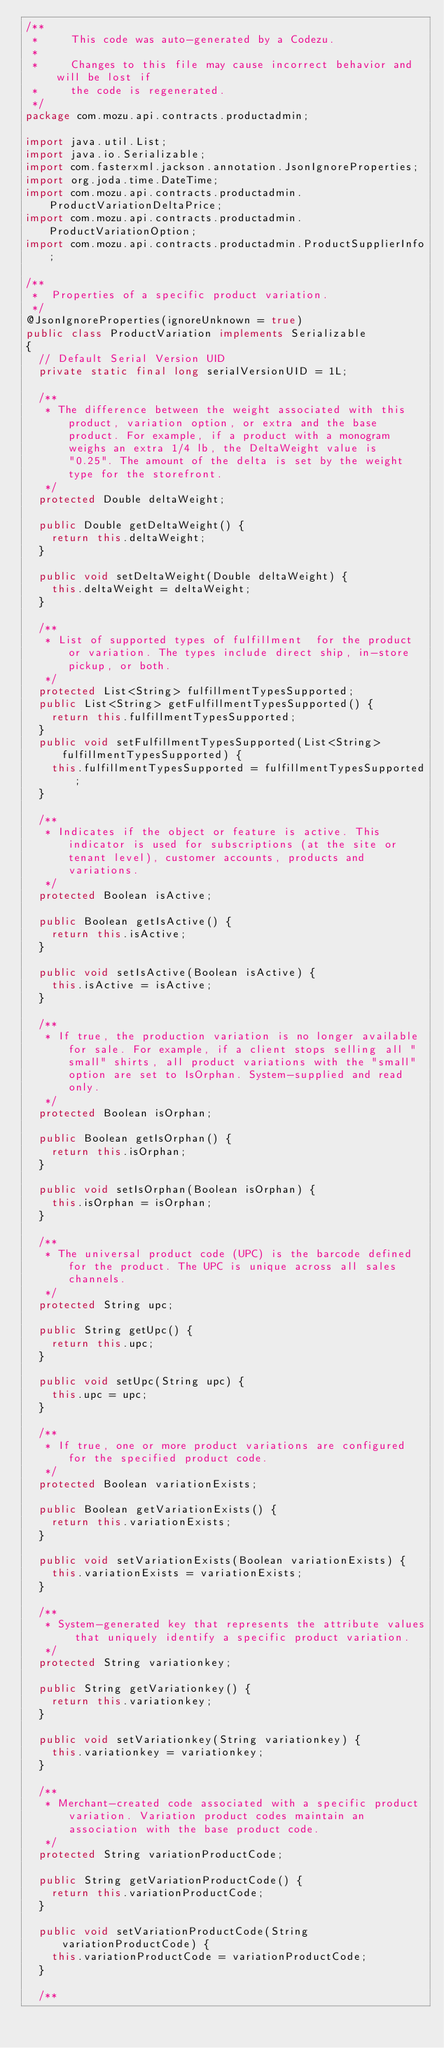Convert code to text. <code><loc_0><loc_0><loc_500><loc_500><_Java_>/**
 *     This code was auto-generated by a Codezu.     
 *
 *     Changes to this file may cause incorrect behavior and will be lost if
 *     the code is regenerated.
 */
package com.mozu.api.contracts.productadmin;

import java.util.List;
import java.io.Serializable;
import com.fasterxml.jackson.annotation.JsonIgnoreProperties;
import org.joda.time.DateTime;
import com.mozu.api.contracts.productadmin.ProductVariationDeltaPrice;
import com.mozu.api.contracts.productadmin.ProductVariationOption;
import com.mozu.api.contracts.productadmin.ProductSupplierInfo;

/**
 *	Properties of a specific product variation.
 */
@JsonIgnoreProperties(ignoreUnknown = true)
public class ProductVariation implements Serializable
{
	// Default Serial Version UID
	private static final long serialVersionUID = 1L;

	/**
	 * The difference between the weight associated with this product, variation option, or extra and the base product. For example, if a product with a monogram weighs an extra 1/4 lb, the DeltaWeight value is "0.25". The amount of the delta is set by the weight type for the storefront.
	 */
	protected Double deltaWeight;

	public Double getDeltaWeight() {
		return this.deltaWeight;
	}

	public void setDeltaWeight(Double deltaWeight) {
		this.deltaWeight = deltaWeight;
	}

	/**
	 * List of supported types of fulfillment  for the product or variation. The types include direct ship, in-store pickup, or both. 
	 */
	protected List<String> fulfillmentTypesSupported;
	public List<String> getFulfillmentTypesSupported() {
		return this.fulfillmentTypesSupported;
	}
	public void setFulfillmentTypesSupported(List<String> fulfillmentTypesSupported) {
		this.fulfillmentTypesSupported = fulfillmentTypesSupported;
	}

	/**
	 * Indicates if the object or feature is active. This indicator is used for subscriptions (at the site or tenant level), customer accounts, products and variations.
	 */
	protected Boolean isActive;

	public Boolean getIsActive() {
		return this.isActive;
	}

	public void setIsActive(Boolean isActive) {
		this.isActive = isActive;
	}

	/**
	 * If true, the production variation is no longer available for sale. For example, if a client stops selling all "small" shirts, all product variations with the "small" option are set to IsOrphan. System-supplied and read only.
	 */
	protected Boolean isOrphan;

	public Boolean getIsOrphan() {
		return this.isOrphan;
	}

	public void setIsOrphan(Boolean isOrphan) {
		this.isOrphan = isOrphan;
	}

	/**
	 * The universal product code (UPC) is the barcode defined for the product. The UPC is unique across all sales channels. 
	 */
	protected String upc;

	public String getUpc() {
		return this.upc;
	}

	public void setUpc(String upc) {
		this.upc = upc;
	}

	/**
	 * If true, one or more product variations are configured for the specified product code.
	 */
	protected Boolean variationExists;

	public Boolean getVariationExists() {
		return this.variationExists;
	}

	public void setVariationExists(Boolean variationExists) {
		this.variationExists = variationExists;
	}

	/**
	 * System-generated key that represents the attribute values that uniquely identify a specific product variation.
	 */
	protected String variationkey;

	public String getVariationkey() {
		return this.variationkey;
	}

	public void setVariationkey(String variationkey) {
		this.variationkey = variationkey;
	}

	/**
	 * Merchant-created code associated with a specific product variation. Variation product codes maintain an association with the base product code.
	 */
	protected String variationProductCode;

	public String getVariationProductCode() {
		return this.variationProductCode;
	}

	public void setVariationProductCode(String variationProductCode) {
		this.variationProductCode = variationProductCode;
	}

	/**</code> 